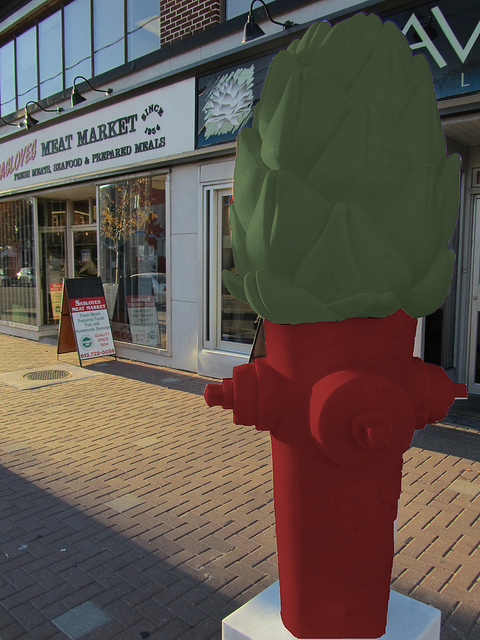<image>What does the street sign say? The street sign is not visible in the image. However, it might say 'meat market'. What does the street sign say? We don't know what the street sign says. There is a possibility that it says "meat market" but we cannot be sure. 